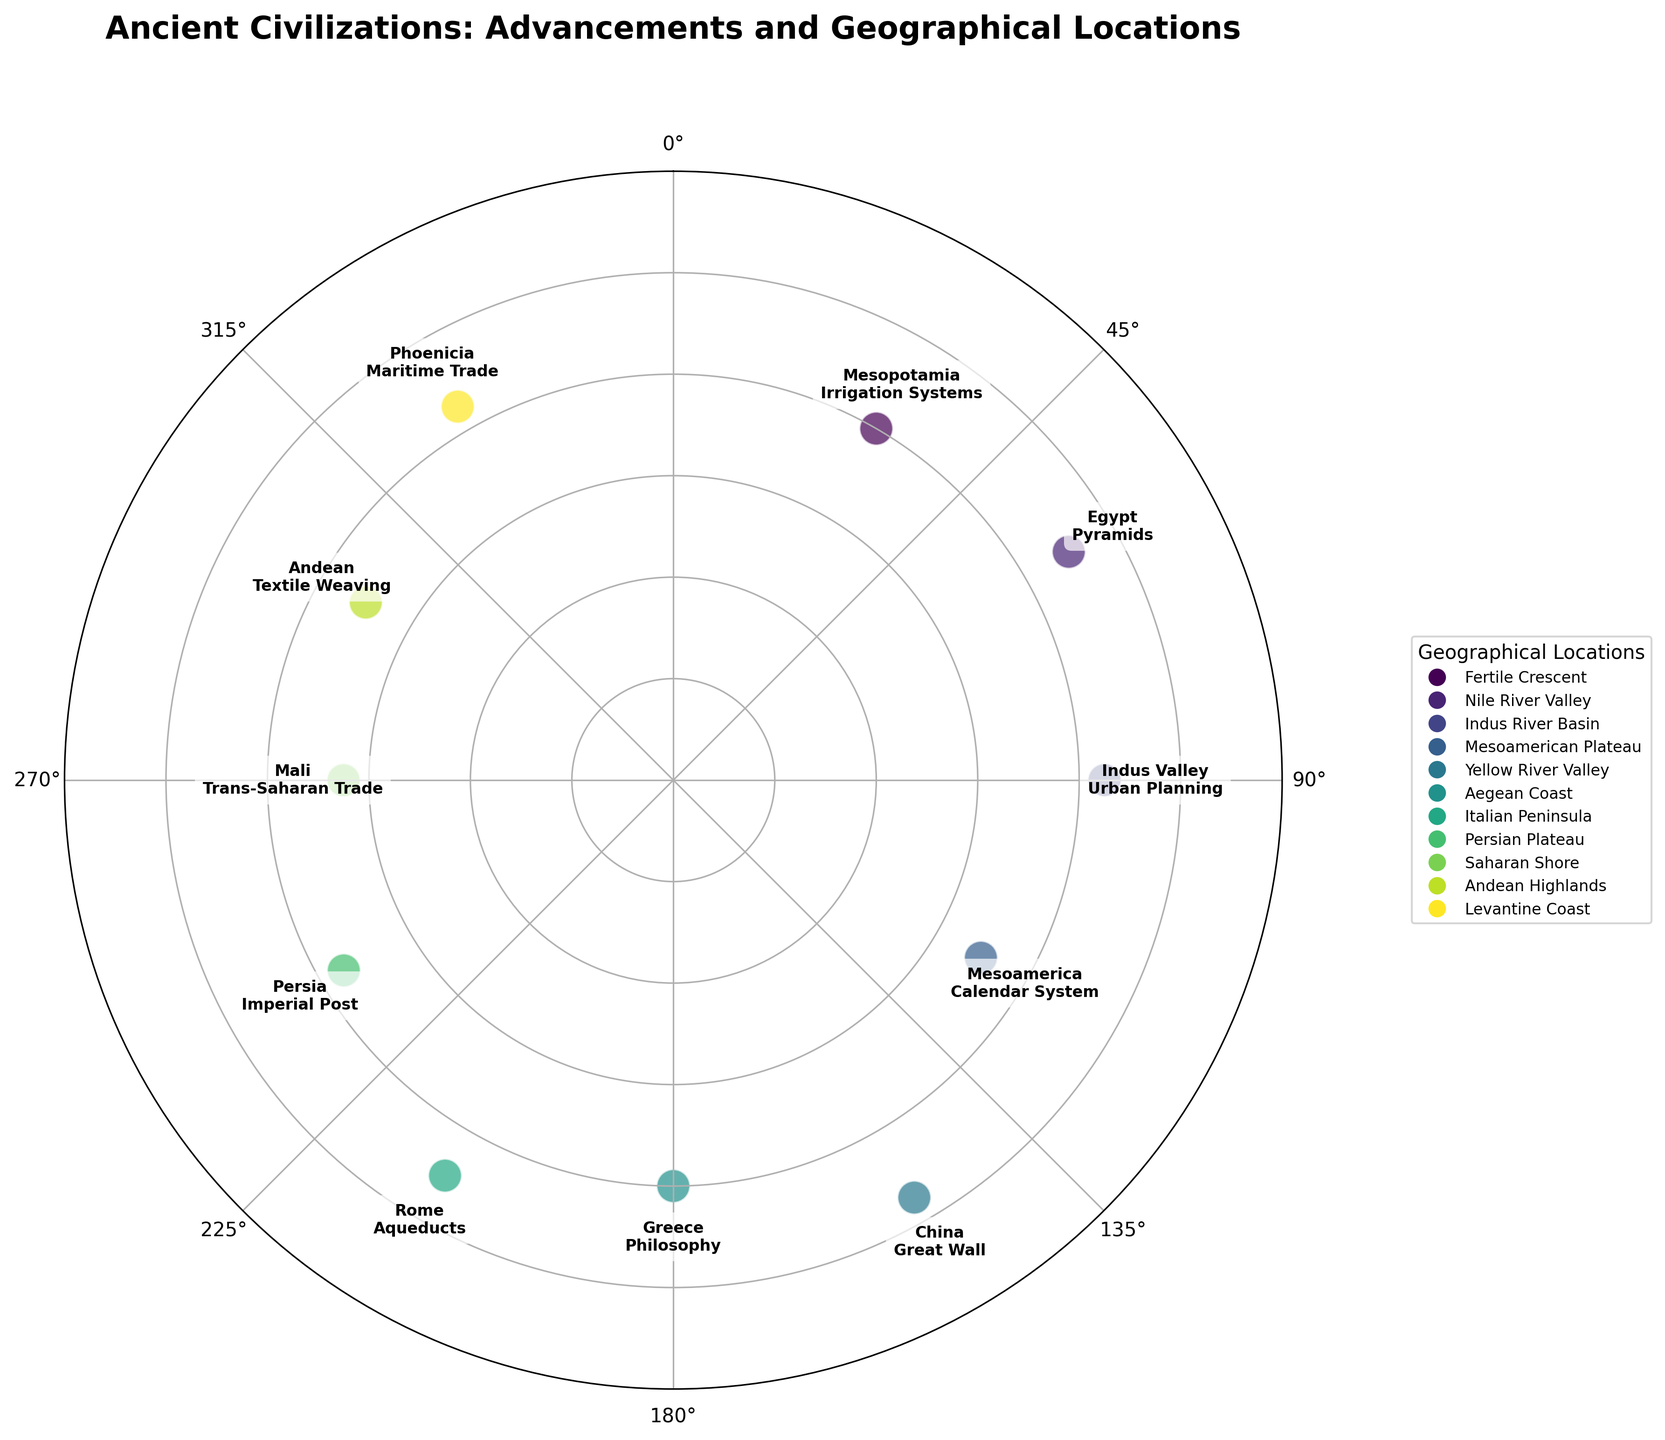What is the title of the figure? The title of the figure is displayed at the top in bold text.
Answer: "Ancient Civilizations: Advancements and Geographical Locations" How many civilizations are represented in the scatter plot? Each civilization corresponds to a point in the scatter plot, and there are annotations for each one. Count the number of annotations.
Answer: 11 Which civilization is located at the highest radius value? Look at the annotated points and find the one with the highest radius value (furthest from the center).
Answer: China (Great Wall) What does the color difference signify in the scatter plot? The legend on the right indicates that different colors represent different geographical locations.
Answer: Geographical locations Are any civilizations located at the same radius? If so, which ones? Check if any two or more points have the same distance from the center (radius value) in the plot.
Answer: Mesopotamia (Irrigation Systems) and Greece (Philosophy) Which civilization is closest to the center, and what is its advancement? Identify the point with the smallest radius value and read its annotation.
Answer: Mali (Trans-Saharan Trade) Compare the radius values of Rome and Egypt. Which civilization has a higher radius? Locate the points for Rome and Egypt and compare their distance from the center.
Answer: Egypt Which geographical location corresponds to the angle of 270 degrees? Identify the annotation at the angle of 270 degrees in the plot.
Answer: Saharan Shore (Mali) How do the advancements of Mesopotamia and Indus Valley civilizations differ geographically? Look at the annotations for Mesopotamia and Indus Valley and note their geographical locations.
Answer: Mesopotamia (Fertile Crescent) and Indus Valley (Indus River Basin) What is the unique feature of civilizations positioned in the top right quadrant of the plot? The top right quadrant typically covers angles from 0 to 90 degrees. Note the features of civilizations in this quadrant.
Answer: Advancements in irrigation systems and urban planning 